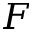Convert formula to latex. <formula><loc_0><loc_0><loc_500><loc_500>F</formula> 